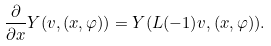<formula> <loc_0><loc_0><loc_500><loc_500>\frac { \partial } { \partial x } Y ( v , ( x , \varphi ) ) = Y ( L ( - 1 ) v , ( x , \varphi ) ) .</formula> 